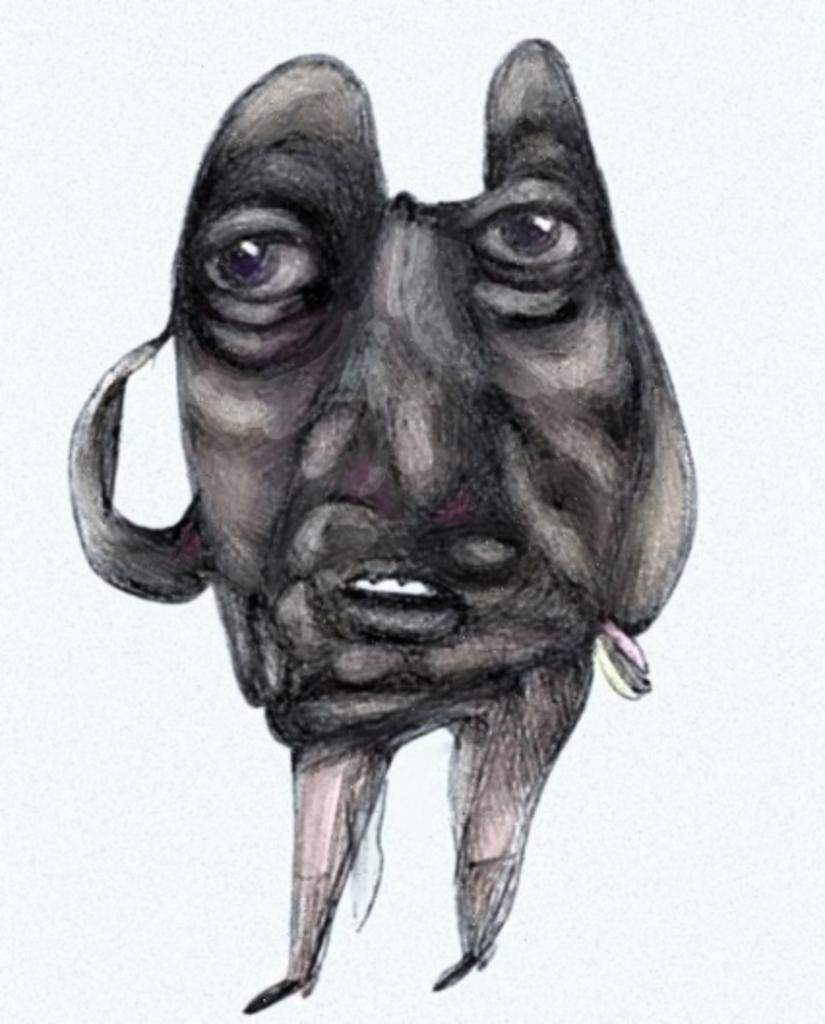Please provide a concise description of this image. In the foreground of this image, there is sketch of a person´s face and legs. 